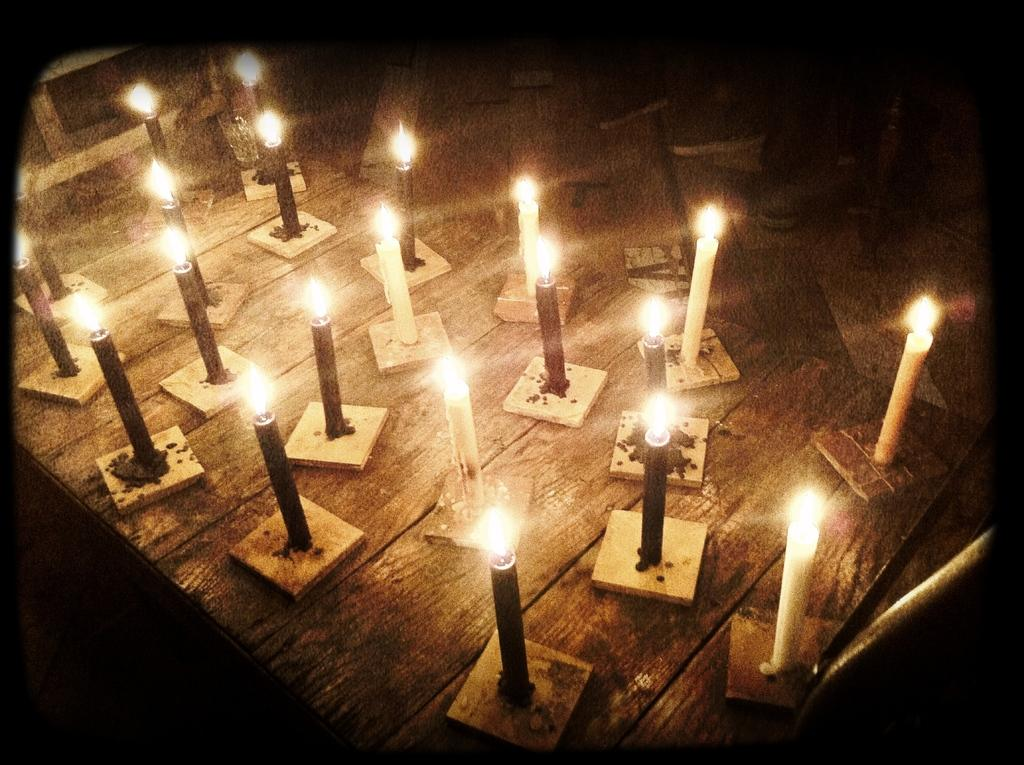What objects are on the table in the image? There are candles on stands on a table in the image. Can you describe the background of the image? The background of the image is blurry. What type of reward is being given to the pear in the image? There is no pear present in the image, and therefore no reward can be given to it. 